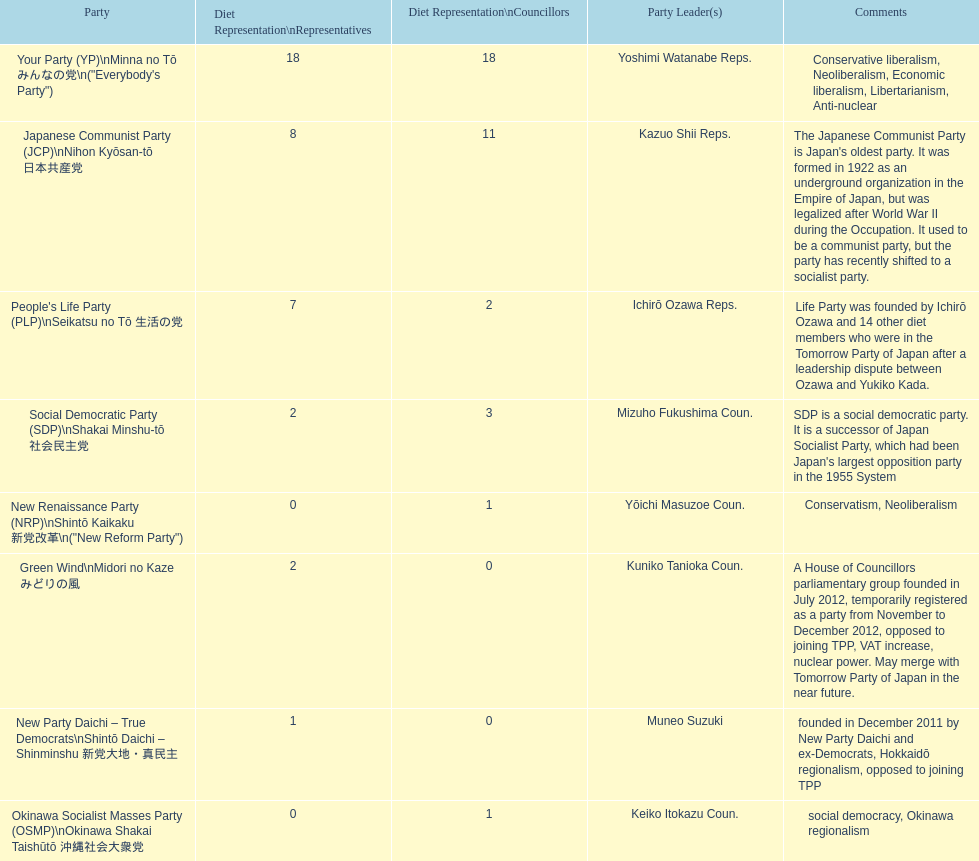According to this table, which party is japan's oldest political party? Japanese Communist Party (JCP) Nihon Kyōsan-tō 日本共産党. 